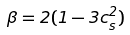Convert formula to latex. <formula><loc_0><loc_0><loc_500><loc_500>\beta = 2 ( 1 - 3 c _ { s } ^ { 2 } )</formula> 